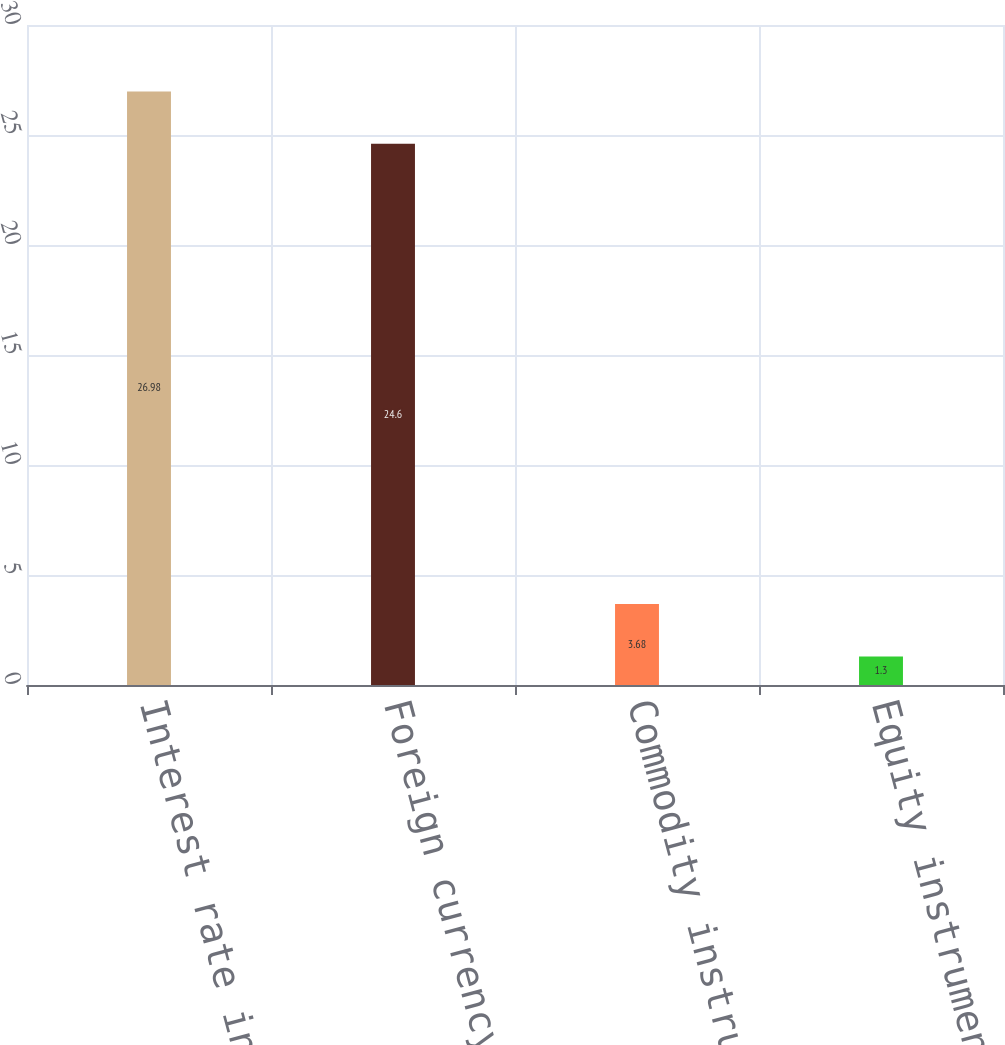<chart> <loc_0><loc_0><loc_500><loc_500><bar_chart><fcel>Interest rate instruments<fcel>Foreign currency instruments<fcel>Commodity instruments<fcel>Equity instruments<nl><fcel>26.98<fcel>24.6<fcel>3.68<fcel>1.3<nl></chart> 